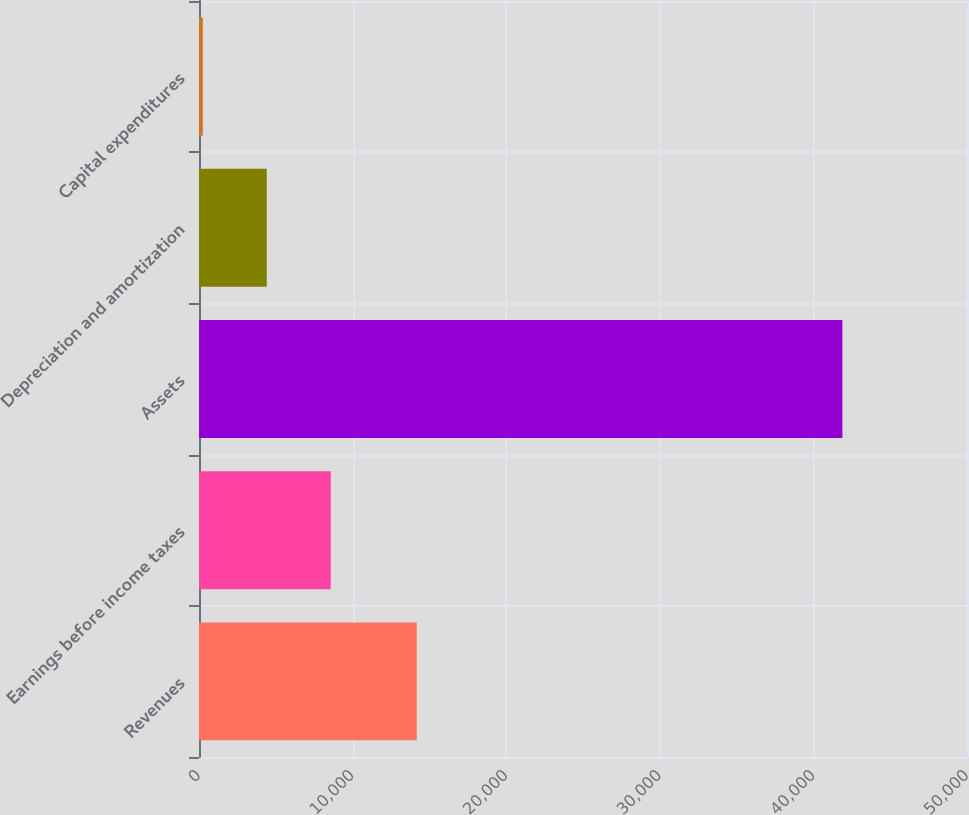<chart> <loc_0><loc_0><loc_500><loc_500><bar_chart><fcel>Revenues<fcel>Earnings before income taxes<fcel>Assets<fcel>Depreciation and amortization<fcel>Capital expenditures<nl><fcel>14175.2<fcel>8576.74<fcel>41887.7<fcel>4412.87<fcel>249<nl></chart> 